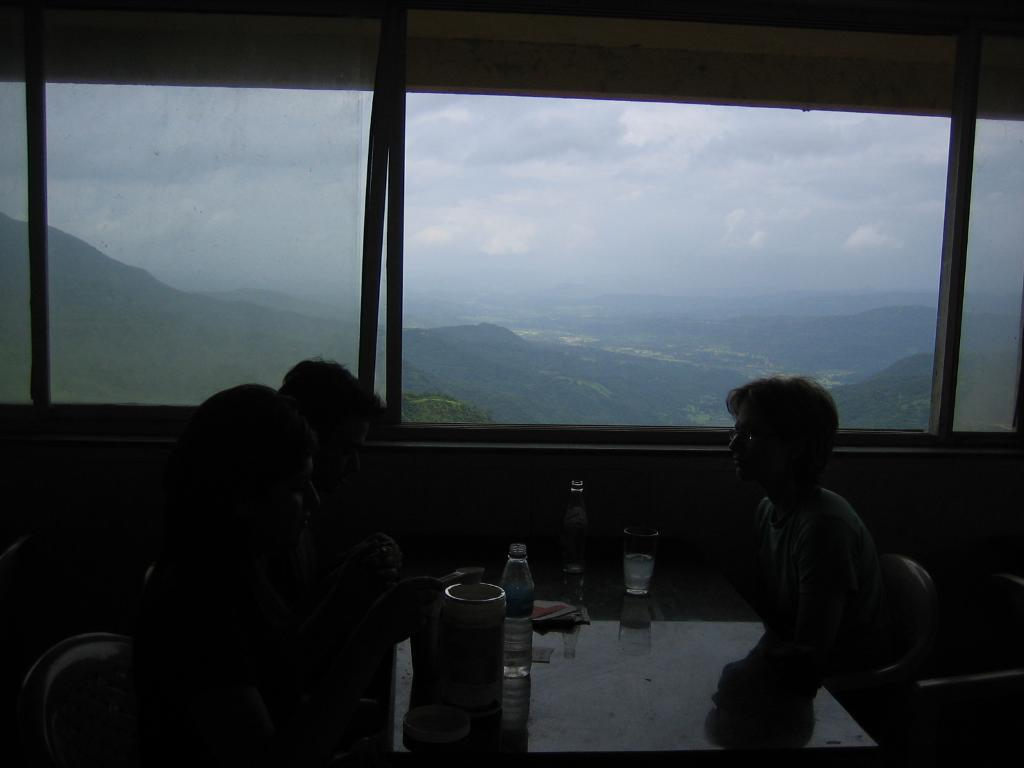What are the people in the image doing? There are persons sitting at the table in the image. What objects can be seen on the table? There are glasses and bottles on the table. What can be seen in the background of the image? There are windows, hills, and sky visible in the background. What is the condition of the sky in the image? The sky is visible in the background, and there are clouds present. What type of holiday is being celebrated in the image? There is no indication of a holiday being celebrated in the image. What is the persons' fear in the image? There is no fear or any indication of fear in the image. 